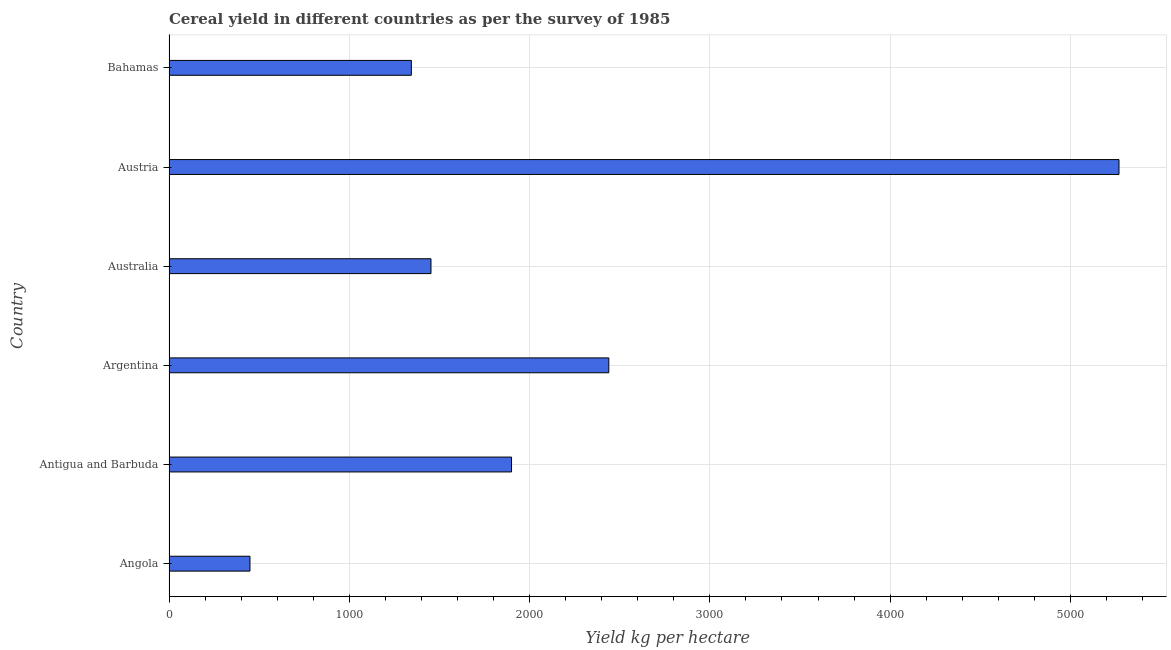Does the graph contain any zero values?
Offer a very short reply. No. Does the graph contain grids?
Offer a very short reply. Yes. What is the title of the graph?
Your answer should be compact. Cereal yield in different countries as per the survey of 1985. What is the label or title of the X-axis?
Your answer should be very brief. Yield kg per hectare. What is the label or title of the Y-axis?
Offer a very short reply. Country. What is the cereal yield in Angola?
Your response must be concise. 449.11. Across all countries, what is the maximum cereal yield?
Give a very brief answer. 5269.44. Across all countries, what is the minimum cereal yield?
Give a very brief answer. 449.11. In which country was the cereal yield maximum?
Offer a terse response. Austria. In which country was the cereal yield minimum?
Make the answer very short. Angola. What is the sum of the cereal yield?
Ensure brevity in your answer.  1.29e+04. What is the difference between the cereal yield in Argentina and Australia?
Provide a short and direct response. 986.47. What is the average cereal yield per country?
Your answer should be compact. 2142.57. What is the median cereal yield?
Provide a succinct answer. 1676.54. In how many countries, is the cereal yield greater than 4800 kg per hectare?
Your answer should be very brief. 1. What is the ratio of the cereal yield in Angola to that in Argentina?
Offer a very short reply. 0.18. What is the difference between the highest and the second highest cereal yield?
Your answer should be compact. 2829.91. Is the sum of the cereal yield in Angola and Bahamas greater than the maximum cereal yield across all countries?
Ensure brevity in your answer.  No. What is the difference between the highest and the lowest cereal yield?
Your response must be concise. 4820.33. In how many countries, is the cereal yield greater than the average cereal yield taken over all countries?
Provide a short and direct response. 2. Are the values on the major ticks of X-axis written in scientific E-notation?
Your answer should be compact. No. What is the Yield kg per hectare in Angola?
Keep it short and to the point. 449.11. What is the Yield kg per hectare in Antigua and Barbuda?
Your answer should be very brief. 1900. What is the Yield kg per hectare of Argentina?
Make the answer very short. 2439.54. What is the Yield kg per hectare of Australia?
Offer a very short reply. 1453.07. What is the Yield kg per hectare of Austria?
Make the answer very short. 5269.44. What is the Yield kg per hectare of Bahamas?
Offer a terse response. 1344.26. What is the difference between the Yield kg per hectare in Angola and Antigua and Barbuda?
Ensure brevity in your answer.  -1450.89. What is the difference between the Yield kg per hectare in Angola and Argentina?
Offer a terse response. -1990.43. What is the difference between the Yield kg per hectare in Angola and Australia?
Offer a terse response. -1003.96. What is the difference between the Yield kg per hectare in Angola and Austria?
Give a very brief answer. -4820.33. What is the difference between the Yield kg per hectare in Angola and Bahamas?
Provide a short and direct response. -895.15. What is the difference between the Yield kg per hectare in Antigua and Barbuda and Argentina?
Provide a short and direct response. -539.54. What is the difference between the Yield kg per hectare in Antigua and Barbuda and Australia?
Provide a short and direct response. 446.93. What is the difference between the Yield kg per hectare in Antigua and Barbuda and Austria?
Make the answer very short. -3369.45. What is the difference between the Yield kg per hectare in Antigua and Barbuda and Bahamas?
Keep it short and to the point. 555.74. What is the difference between the Yield kg per hectare in Argentina and Australia?
Offer a terse response. 986.47. What is the difference between the Yield kg per hectare in Argentina and Austria?
Your answer should be very brief. -2829.91. What is the difference between the Yield kg per hectare in Argentina and Bahamas?
Ensure brevity in your answer.  1095.28. What is the difference between the Yield kg per hectare in Australia and Austria?
Give a very brief answer. -3816.37. What is the difference between the Yield kg per hectare in Australia and Bahamas?
Offer a terse response. 108.81. What is the difference between the Yield kg per hectare in Austria and Bahamas?
Offer a very short reply. 3925.18. What is the ratio of the Yield kg per hectare in Angola to that in Antigua and Barbuda?
Offer a terse response. 0.24. What is the ratio of the Yield kg per hectare in Angola to that in Argentina?
Provide a succinct answer. 0.18. What is the ratio of the Yield kg per hectare in Angola to that in Australia?
Keep it short and to the point. 0.31. What is the ratio of the Yield kg per hectare in Angola to that in Austria?
Make the answer very short. 0.09. What is the ratio of the Yield kg per hectare in Angola to that in Bahamas?
Provide a succinct answer. 0.33. What is the ratio of the Yield kg per hectare in Antigua and Barbuda to that in Argentina?
Ensure brevity in your answer.  0.78. What is the ratio of the Yield kg per hectare in Antigua and Barbuda to that in Australia?
Ensure brevity in your answer.  1.31. What is the ratio of the Yield kg per hectare in Antigua and Barbuda to that in Austria?
Keep it short and to the point. 0.36. What is the ratio of the Yield kg per hectare in Antigua and Barbuda to that in Bahamas?
Your response must be concise. 1.41. What is the ratio of the Yield kg per hectare in Argentina to that in Australia?
Your answer should be compact. 1.68. What is the ratio of the Yield kg per hectare in Argentina to that in Austria?
Your answer should be compact. 0.46. What is the ratio of the Yield kg per hectare in Argentina to that in Bahamas?
Make the answer very short. 1.81. What is the ratio of the Yield kg per hectare in Australia to that in Austria?
Offer a very short reply. 0.28. What is the ratio of the Yield kg per hectare in Australia to that in Bahamas?
Give a very brief answer. 1.08. What is the ratio of the Yield kg per hectare in Austria to that in Bahamas?
Keep it short and to the point. 3.92. 